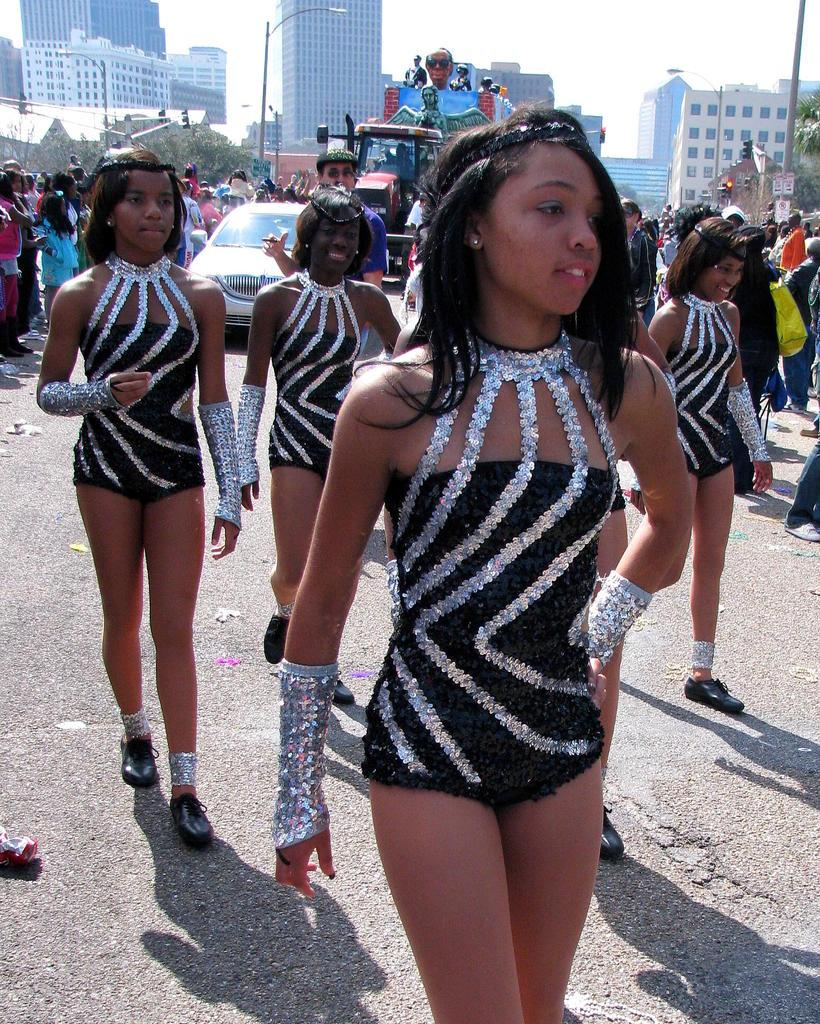What are the girls in the image doing? The girls in the image are walking on the road. What can be seen in the background of the image? In the background, there are vehicles, buildings, trees, light poles, and people. What is visible in the sky? The sky is visible in the image. What type of skin can be seen on the letters in the image? There are no letters present in the image, so there is no skin to be observed. 